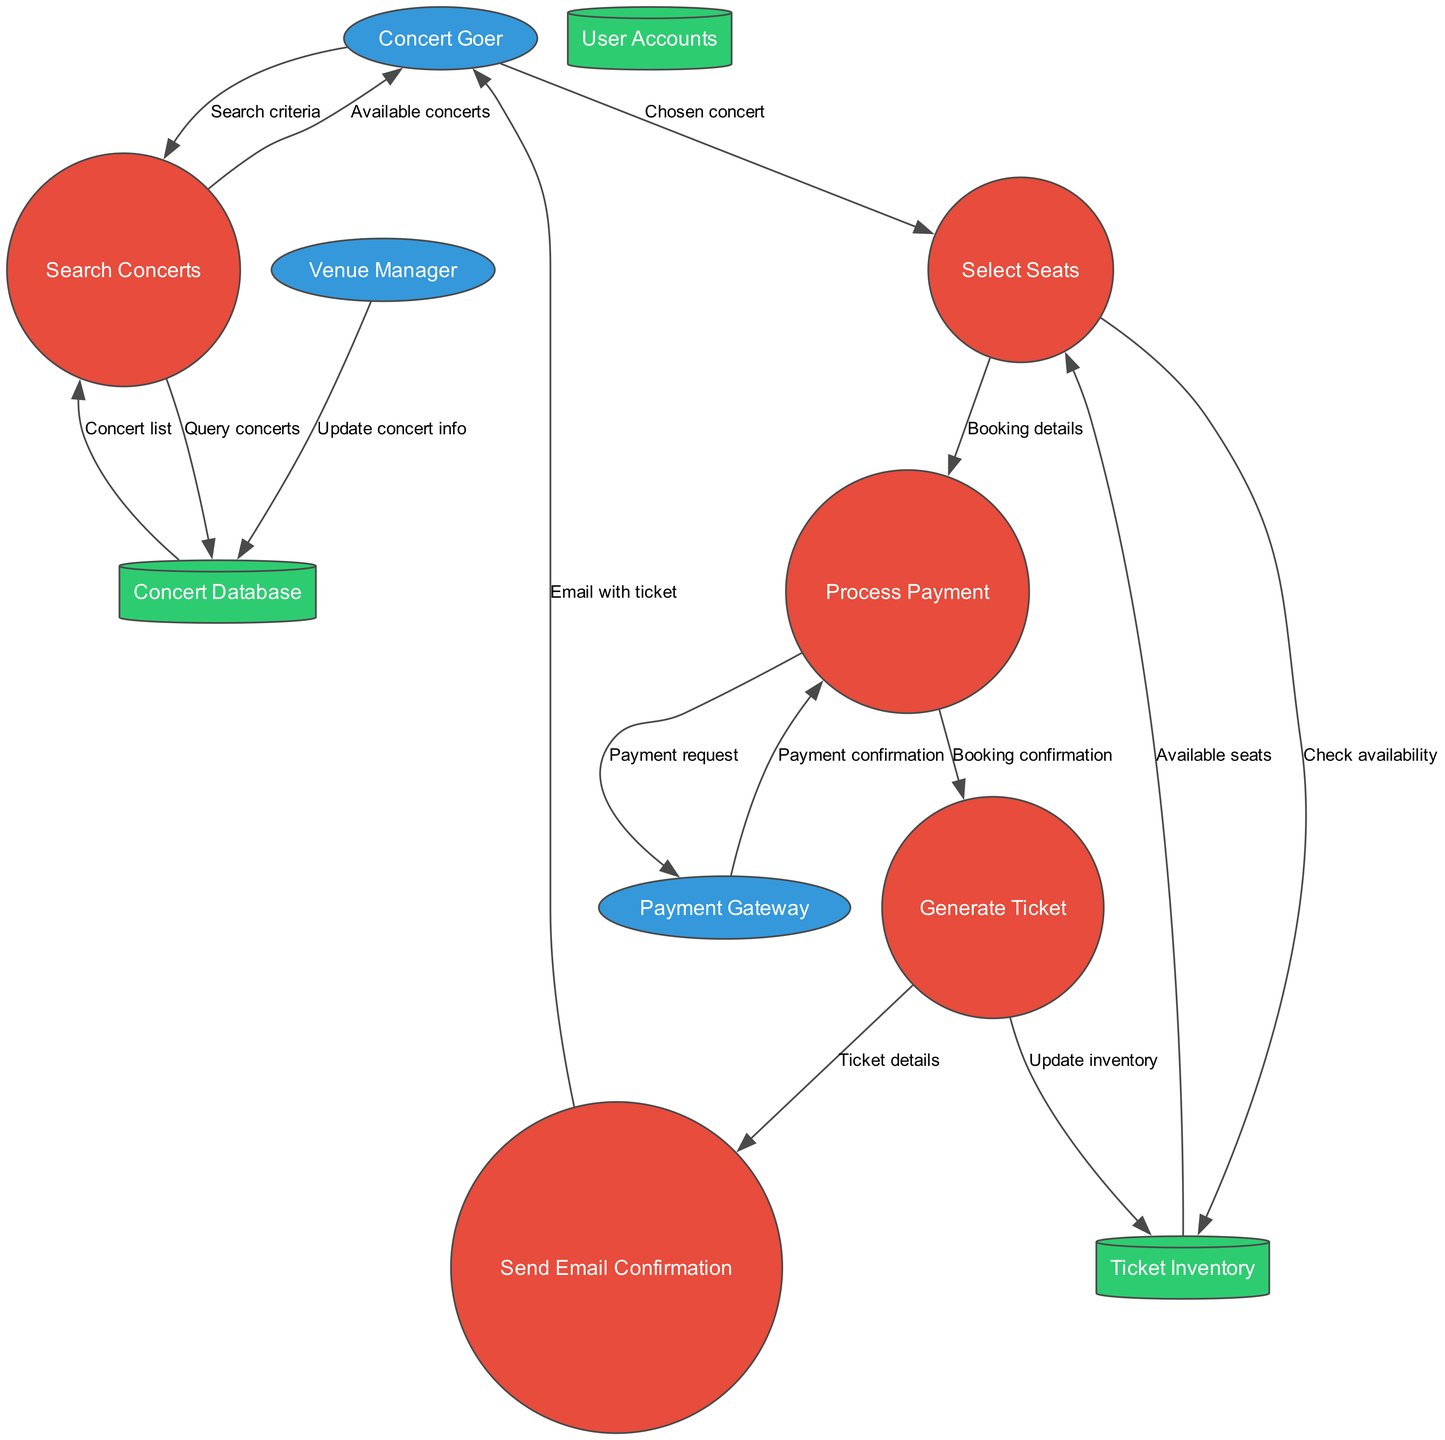What are the external entities in the diagram? The diagram lists three external entities: Concert Goer, Payment Gateway, and Venue Manager. These entities are represented as ellipses in the diagram.
Answer: Concert Goer, Payment Gateway, Venue Manager How many processes are shown in the diagram? The diagram depicts five distinct processes that are illustrated as circles. These processes include Search Concerts, Select Seats, Process Payment, Generate Ticket, and Send Email Confirmation.
Answer: 5 What data store is linked to the Select Seats process? The Select Seats process connects to the Ticket Inventory data store, which is a cylinder shape in the diagram. Data flows include a check for seat availability.
Answer: Ticket Inventory What flows from the Process Payment to the Payment Gateway? The data flow labeled "Payment request" moves from Process Payment to Payment Gateway, indicating a request for transaction processing with specific payment details.
Answer: Payment request What is the final step after generating a ticket? After generating a ticket, the next step is to send an email confirmation to the concert goer, which includes the details of the ticket.
Answer: Send Email Confirmation How does the Concert Goer obtain available concerts? The Concert Goer initially inputs search criteria, which flows into the Search Concerts process. This process queries the Concert Database, sending back a list of available concerts.
Answer: Concert list What updates the Concert Database with new information? The Venue Manager is responsible for updating the Concert Database, which involves modifying or adding new concert information as needed.
Answer: Update concert info What does the Generate Ticket process update? The Generate Ticket process updates the Ticket Inventory to reflect the new bookings and available seats post-concert ticket generation.
Answer: Update inventory What confirms the payment in the booking process? The Payment Gateway sends back a "Payment confirmation" to the Process Payment, ensuring that the payment was successful before proceeding further in the booking flow.
Answer: Payment confirmation 